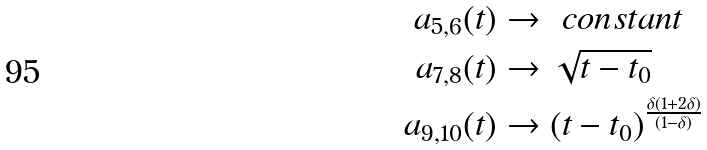Convert formula to latex. <formula><loc_0><loc_0><loc_500><loc_500>a _ { 5 , 6 } ( t ) & \rightarrow \ c o n s t a n t \\ a _ { 7 , 8 } ( t ) & \rightarrow \sqrt { t - t _ { 0 } } \\ a _ { 9 , 1 0 } ( t ) & \rightarrow ( t - t _ { 0 } ) ^ { \frac { \delta ( 1 + 2 \delta ) } { ( 1 - \delta ) } }</formula> 